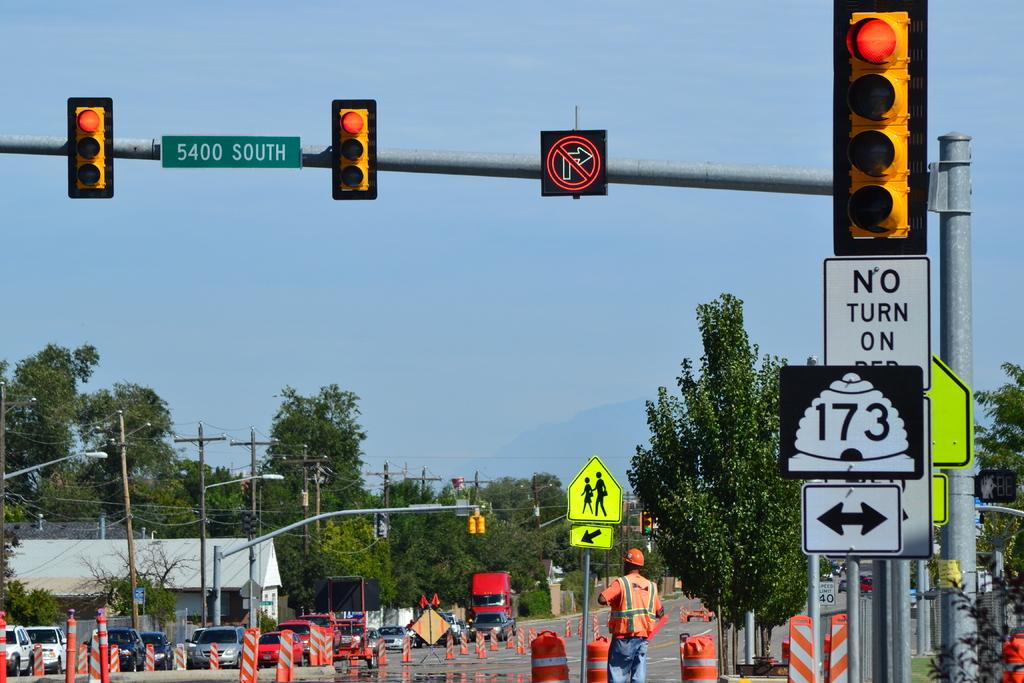<image>
Describe the image concisely. The traffic lights at the 5400 South intersection are red. 